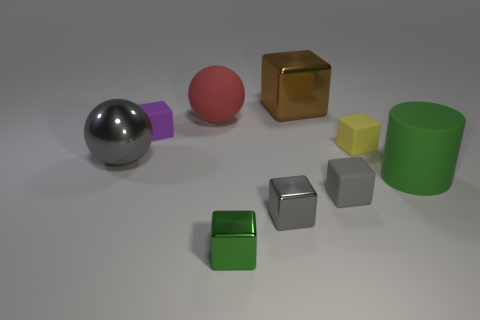There is a metal thing that is the same color as the metallic sphere; what size is it? The metallic object that shares the same silver-gray color as the metallic sphere appears to be a small cube, roughly similar in size to the other smaller cubes visible in the image, indicating that it's a small object. 